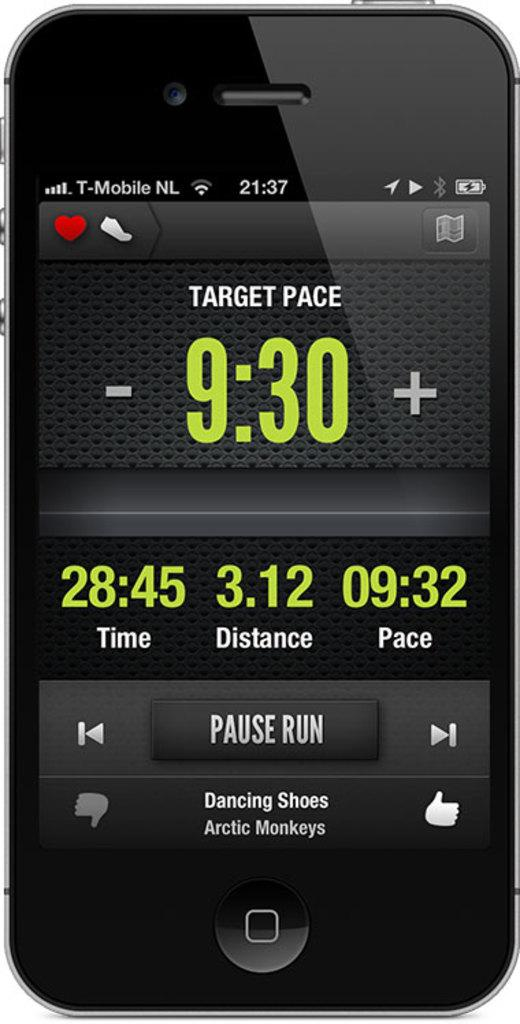What object is present in the image? There is a mobile in the image. What can be seen on the mobile screen? There are symbols visible on the mobile screen. What is the income of the person on stage in the image? There is no stage or person present in the image; it only features a mobile with symbols on the screen. 